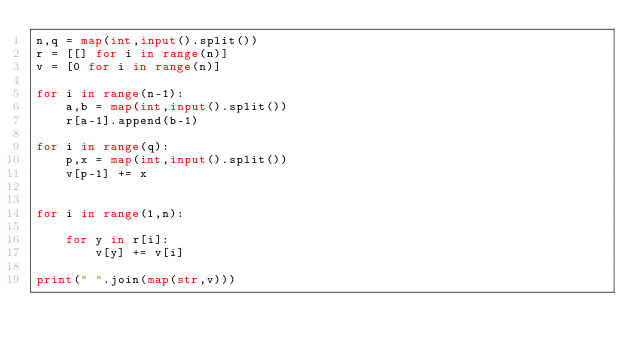Convert code to text. <code><loc_0><loc_0><loc_500><loc_500><_Python_>n,q = map(int,input().split())
r = [[] for i in range(n)]
v = [0 for i in range(n)]

for i in range(n-1):
    a,b = map(int,input().split())
    r[a-1].append(b-1)

for i in range(q):
    p,x = map(int,input().split())
    v[p-1] += x


for i in range(1,n):

    for y in r[i]:
        v[y] += v[i]

print(" ".join(map(str,v)))</code> 